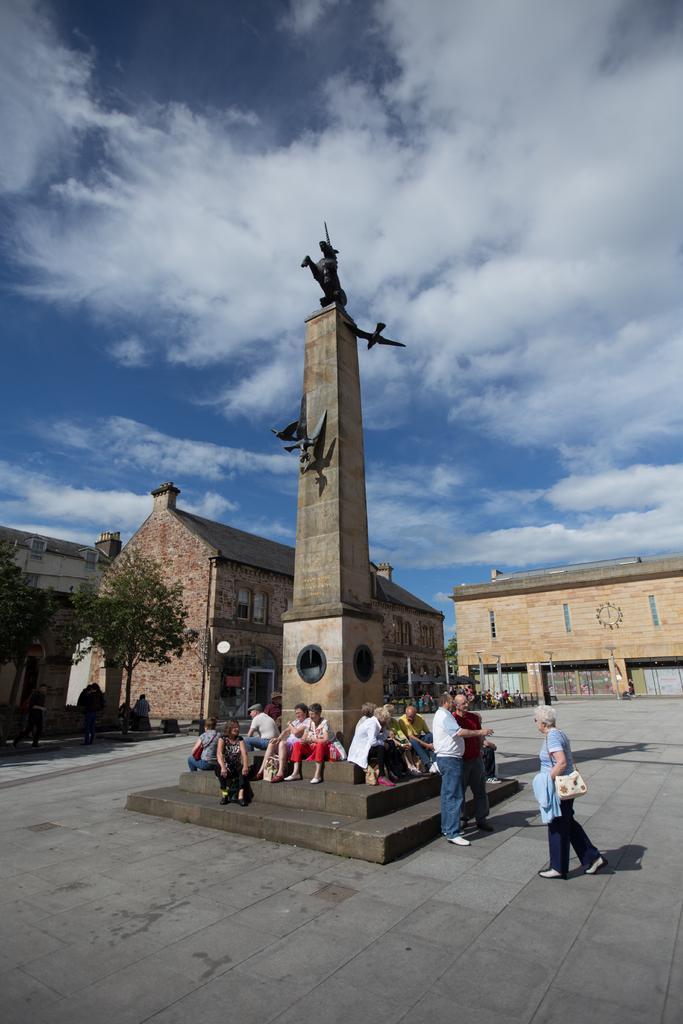Could you give a brief overview of what you see in this image? In this image I can see people among them some are sitting and some are standing on the ground. Here I can see statue. In the background I can see buildings, trees and the sky. 